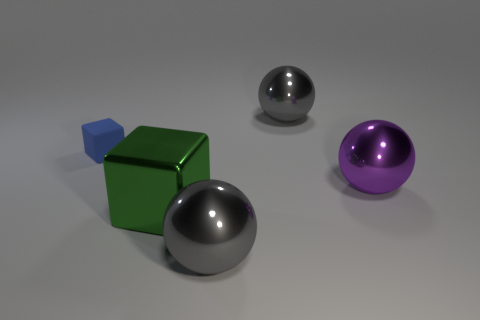There is a large gray shiny thing that is behind the large purple sphere; are there any tiny blue blocks behind it?
Your answer should be very brief. No. Are there any other things that have the same shape as the tiny matte thing?
Offer a terse response. Yes. Does the rubber thing have the same size as the green block?
Give a very brief answer. No. What is the material of the gray sphere that is behind the gray thing that is to the left of the big object behind the purple metal thing?
Your answer should be very brief. Metal. Are there an equal number of blue matte cubes in front of the small blue matte cube and tiny matte objects?
Keep it short and to the point. No. Are there any other things that have the same size as the green metal cube?
Make the answer very short. Yes. How many objects are blocks or big purple things?
Provide a short and direct response. 3. What is the shape of the purple thing that is made of the same material as the green block?
Your answer should be compact. Sphere. What is the size of the gray object that is to the right of the large shiny sphere that is in front of the large purple metallic ball?
Offer a terse response. Large. How many small things are gray rubber cylinders or purple things?
Your answer should be compact. 0. 